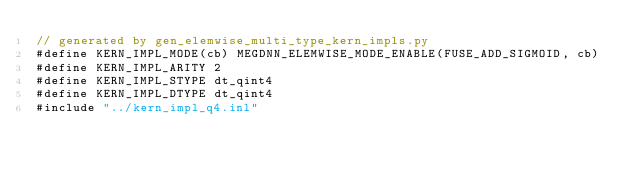Convert code to text. <code><loc_0><loc_0><loc_500><loc_500><_Cuda_>// generated by gen_elemwise_multi_type_kern_impls.py
#define KERN_IMPL_MODE(cb) MEGDNN_ELEMWISE_MODE_ENABLE(FUSE_ADD_SIGMOID, cb)
#define KERN_IMPL_ARITY 2
#define KERN_IMPL_STYPE dt_qint4
#define KERN_IMPL_DTYPE dt_qint4
#include "../kern_impl_q4.inl"
</code> 